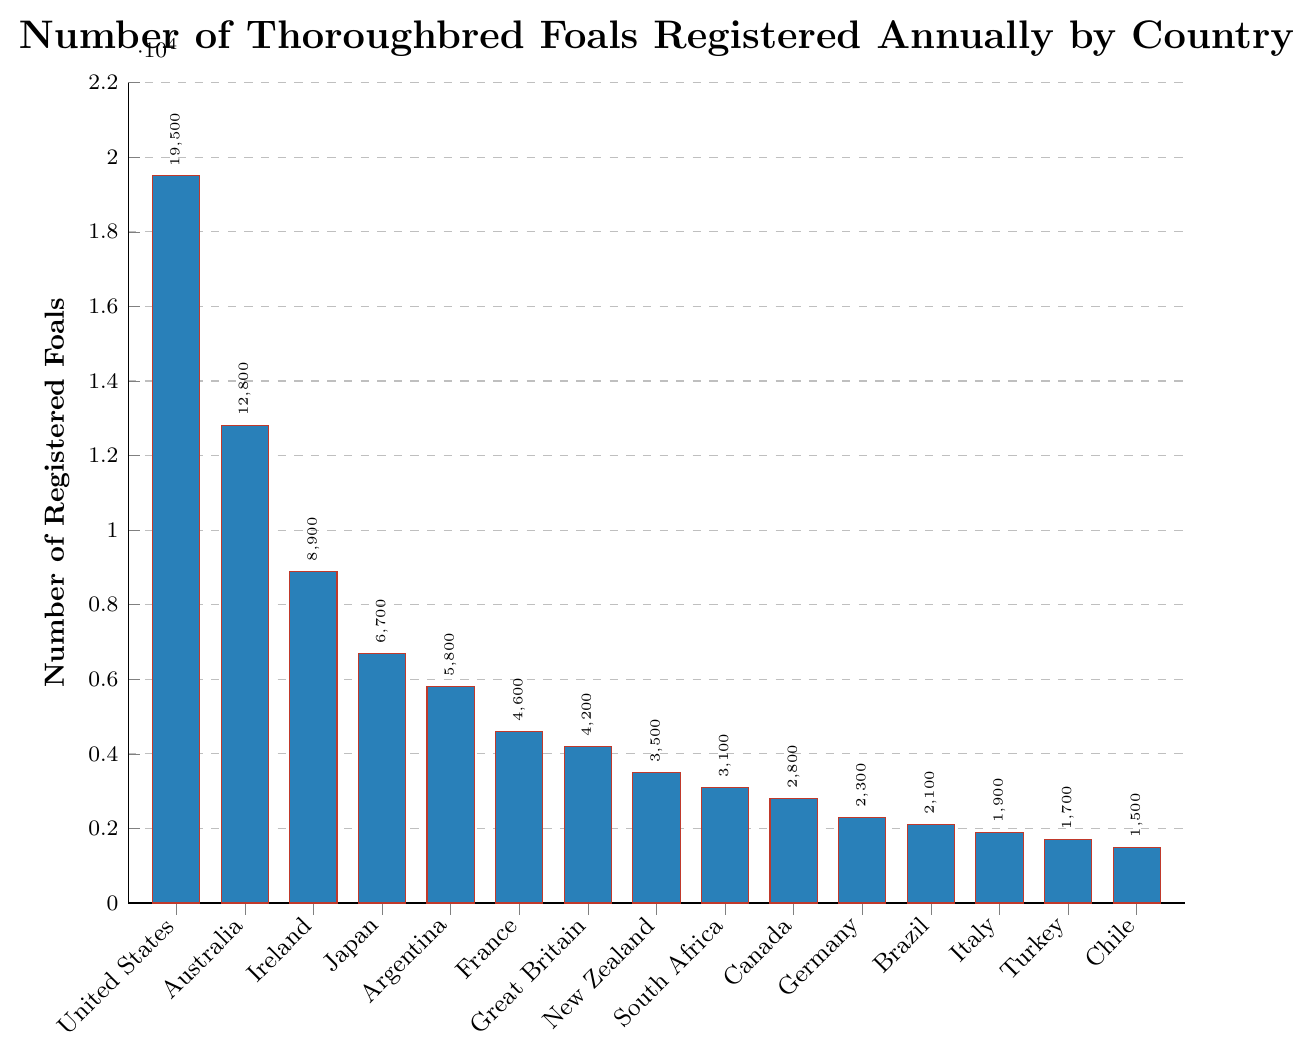Which country has the highest number of registered foals? The bar for the United States is the tallest in the chart, indicating the highest number of registered foals.
Answer: United States What is the difference in the number of registered foals between Japan and France? From the chart, Japan has 6700 foals and France has 4600 foals. Subtracting these: 6700 - 4600 = 2100
Answer: 2100 Which countries have fewer than 3000 registered foals? Check the height of the bars that are shorter than the one indicating 3000 foals. These countries are Canada, Germany, Brazil, Italy, Turkey, and Chile.
Answer: Canada, Germany, Brazil, Italy, Turkey, Chile What is the average number of registered foals across all the given countries? Sum the number of foals for all countries (19500 + 12800 + 8900 + 6700 + 5800 + 4600 + 4200 + 3500 + 3100 + 2800 + 2300 + 2100 + 1900 + 1700 + 1500) = 84100. Divide by the number of countries (15). 84100 / 15 = 5606.67
Answer: 5606.67 How many countries have more registered foals than Germany? Identify the bars taller than Germany’s bar indicating 2300 foals. These countries are United States, Australia, Ireland, Japan, Argentina, France, Great Britain, New Zealand, South Africa, and Canada, totaling 10 countries.
Answer: 10 What is the combined number of registered foals for the countries in the Southern Hemisphere listed in the chart? Add the number of registered foals for Australia (12800), Argentina (5800), New Zealand (3500), South Africa (3100), and Chile (1500). 12800 + 5800 + 3500 + 3100 + 1500 = 26700
Answer: 26700 Which country has the second least number of registered foals? Sorting the values in ascending order, Chile has the least with 1500 foals, and the next smallest bar represents Turkey with 1700 foals.
Answer: Turkey What is the total number of registered foals in European countries listed in the chart? Add the number of registered foals for Ireland (8900), France (4600), Great Britain (4200), Germany (2300), Italy (1900), and Turkey (1700). 8900 + 4600 + 4200 + 2300 + 1900 + 1700 = 23600
Answer: 23600 Which has more registered foals, Japan or the combined total of South Africa and Canada? Japan has 6700 foals. South Africa has 3100, and Canada has 2800. Combine South Africa and Canada: 3100 + 2800 = 5900. Since 6700 is greater than 5900, Japan has more.
Answer: Japan Is the number of registered foals in the United States more than twice that in Ireland? The United States has 19500 foals, and Ireland has 8900. Double the number for Ireland is 8900 x 2 = 17800. Since 19500 is greater than 17800, the United States has more than twice the number.
Answer: Yes 